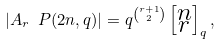Convert formula to latex. <formula><loc_0><loc_0><loc_500><loc_500>| A _ { r } \ P ( 2 n , q ) | = q ^ { \binom { r + 1 } { 2 } } \left [ \substack { n \\ r } \right ] _ { q } ,</formula> 